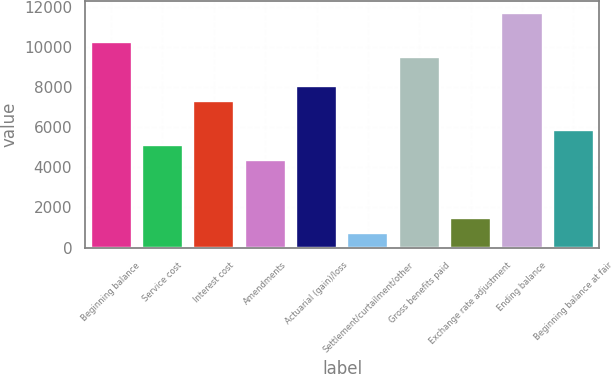<chart> <loc_0><loc_0><loc_500><loc_500><bar_chart><fcel>Beginning balance<fcel>Service cost<fcel>Interest cost<fcel>Amendments<fcel>Actuarial (gain)/loss<fcel>Settlement/curtailment/other<fcel>Gross benefits paid<fcel>Exchange rate adjustment<fcel>Ending balance<fcel>Beginning balance at fair<nl><fcel>10227.6<fcel>5114.8<fcel>7306<fcel>4384.4<fcel>8036.4<fcel>732.4<fcel>9497.2<fcel>1462.8<fcel>11688.4<fcel>5845.2<nl></chart> 